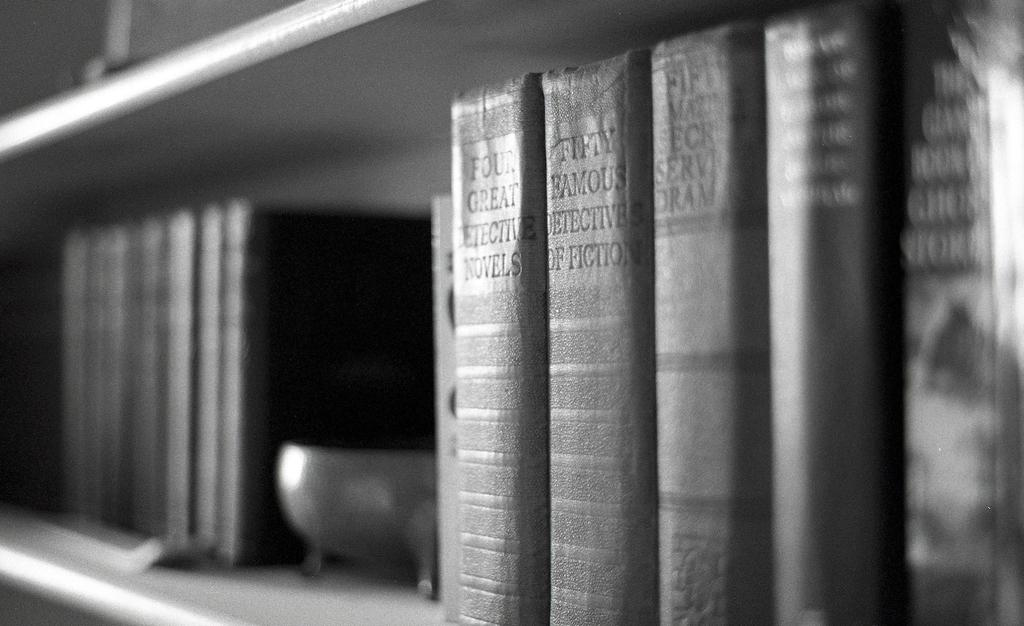What activity is taking place in the image? There is a race depicted in the image. What objects can be seen in the image besides the race? There are books on a rack in the image. What is the color scheme of the artistically used in the image? The image is black and white. What type of cork can be seen being used by the racers in the image? There is no cork present in the image; it depicts a race with no specific equipment mentioned. Is there a club visible in the image? There is no club present in the image; it only shows a race and books on a rack. 